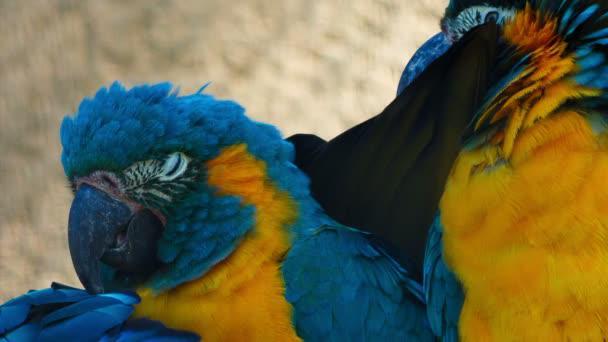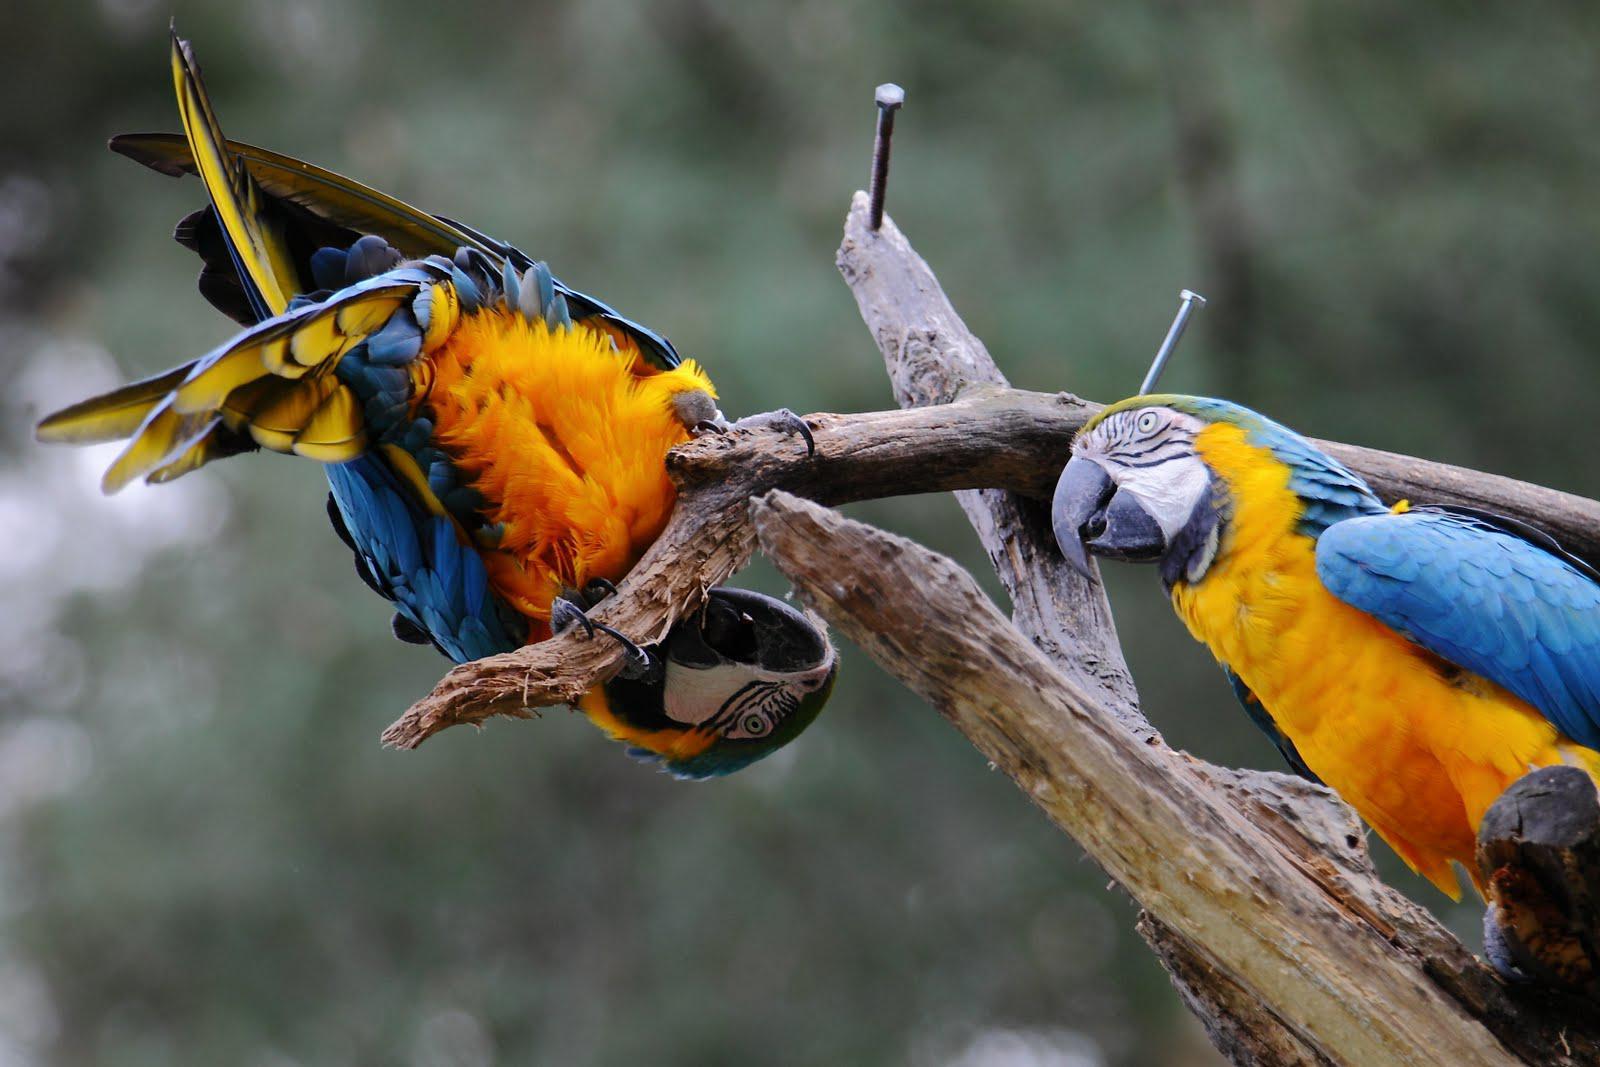The first image is the image on the left, the second image is the image on the right. Assess this claim about the two images: "All birds shown have blue and yellow coloring, and at least one bird has its yellow belly facing the camera.". Correct or not? Answer yes or no. Yes. The first image is the image on the left, the second image is the image on the right. Given the left and right images, does the statement "Two parrots nuzzle, in the image on the right." hold true? Answer yes or no. No. 